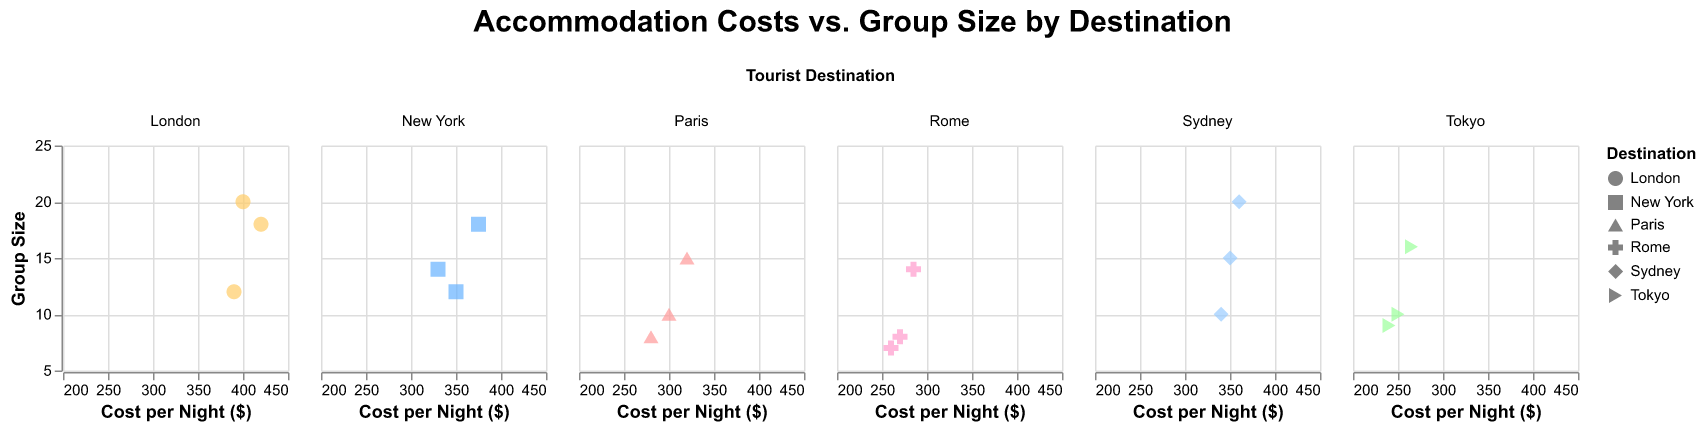What is the title of the figure? The title is prominently displayed above the subplots. It indicates the main focus of the visual.
Answer: Accommodation Costs vs. Group Size by Destination Which destination has the highest accommodation cost per night? In the subplot for London, it shows a point at $420, which is the highest given the specified x-axis range.
Answer: London What is the range of accommodation costs for Rome? The data points for Rome on the x-axis range from $260 to $285.
Answer: $260 to $285 Which destination has the widest range of group sizes? By comparing the y-axis values across subplots, London has data points ranging from group sizes 12 to 20, a span of 8.
Answer: London What is the average accommodation cost per night for Tokyo? The accommodation costs for Tokyo are $250, $265, and $240. Adding them: 250 + 265 + 240 = 755. Dividing by the number of data points: 755/3 = 251.67
Answer: $251.67 Which destination has the lowest accommodation cost per night? The subplot for Tokyo shows a point at $240, which is the lowest among all the specified x-axis ranges.
Answer: Tokyo How does the accommodation cost for the largest group size in New York compare to the smallest group size in the same destination? The largest group size in New York is 18 with a cost of $375, and the smallest group size is 12 with a cost of $350. This indicates a higher cost for larger group size.
Answer: Higher for largest group size Does Sydney's accommodation cost vary greatly with changing group sizes? Examining Sydney's subplot, all points range closely around $340 to $360 across various group sizes (10 to 20). This shows limited cost variation.
Answer: Limited cost variation Which destination appears the most frequently in the dataset? By counting data points per subplot, New York and Tokyo each have 3 data points; however, all other destinations also have 3 points. Thus, no destination appears more frequently than another.
Answer: All are equal Are there any overlapping accommodation costs between Paris and Sydney for certain group sizes? Observing the subplots, Paris has costs from $280 to $320 and Sydney from $340 to $360. There is no overlap in accommodation costs for these destinations.
Answer: No overlap 